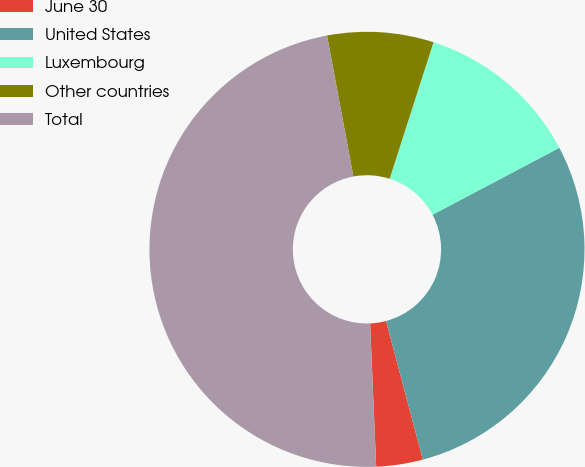Convert chart. <chart><loc_0><loc_0><loc_500><loc_500><pie_chart><fcel>June 30<fcel>United States<fcel>Luxembourg<fcel>Other countries<fcel>Total<nl><fcel>3.46%<fcel>28.6%<fcel>12.32%<fcel>7.89%<fcel>47.73%<nl></chart> 